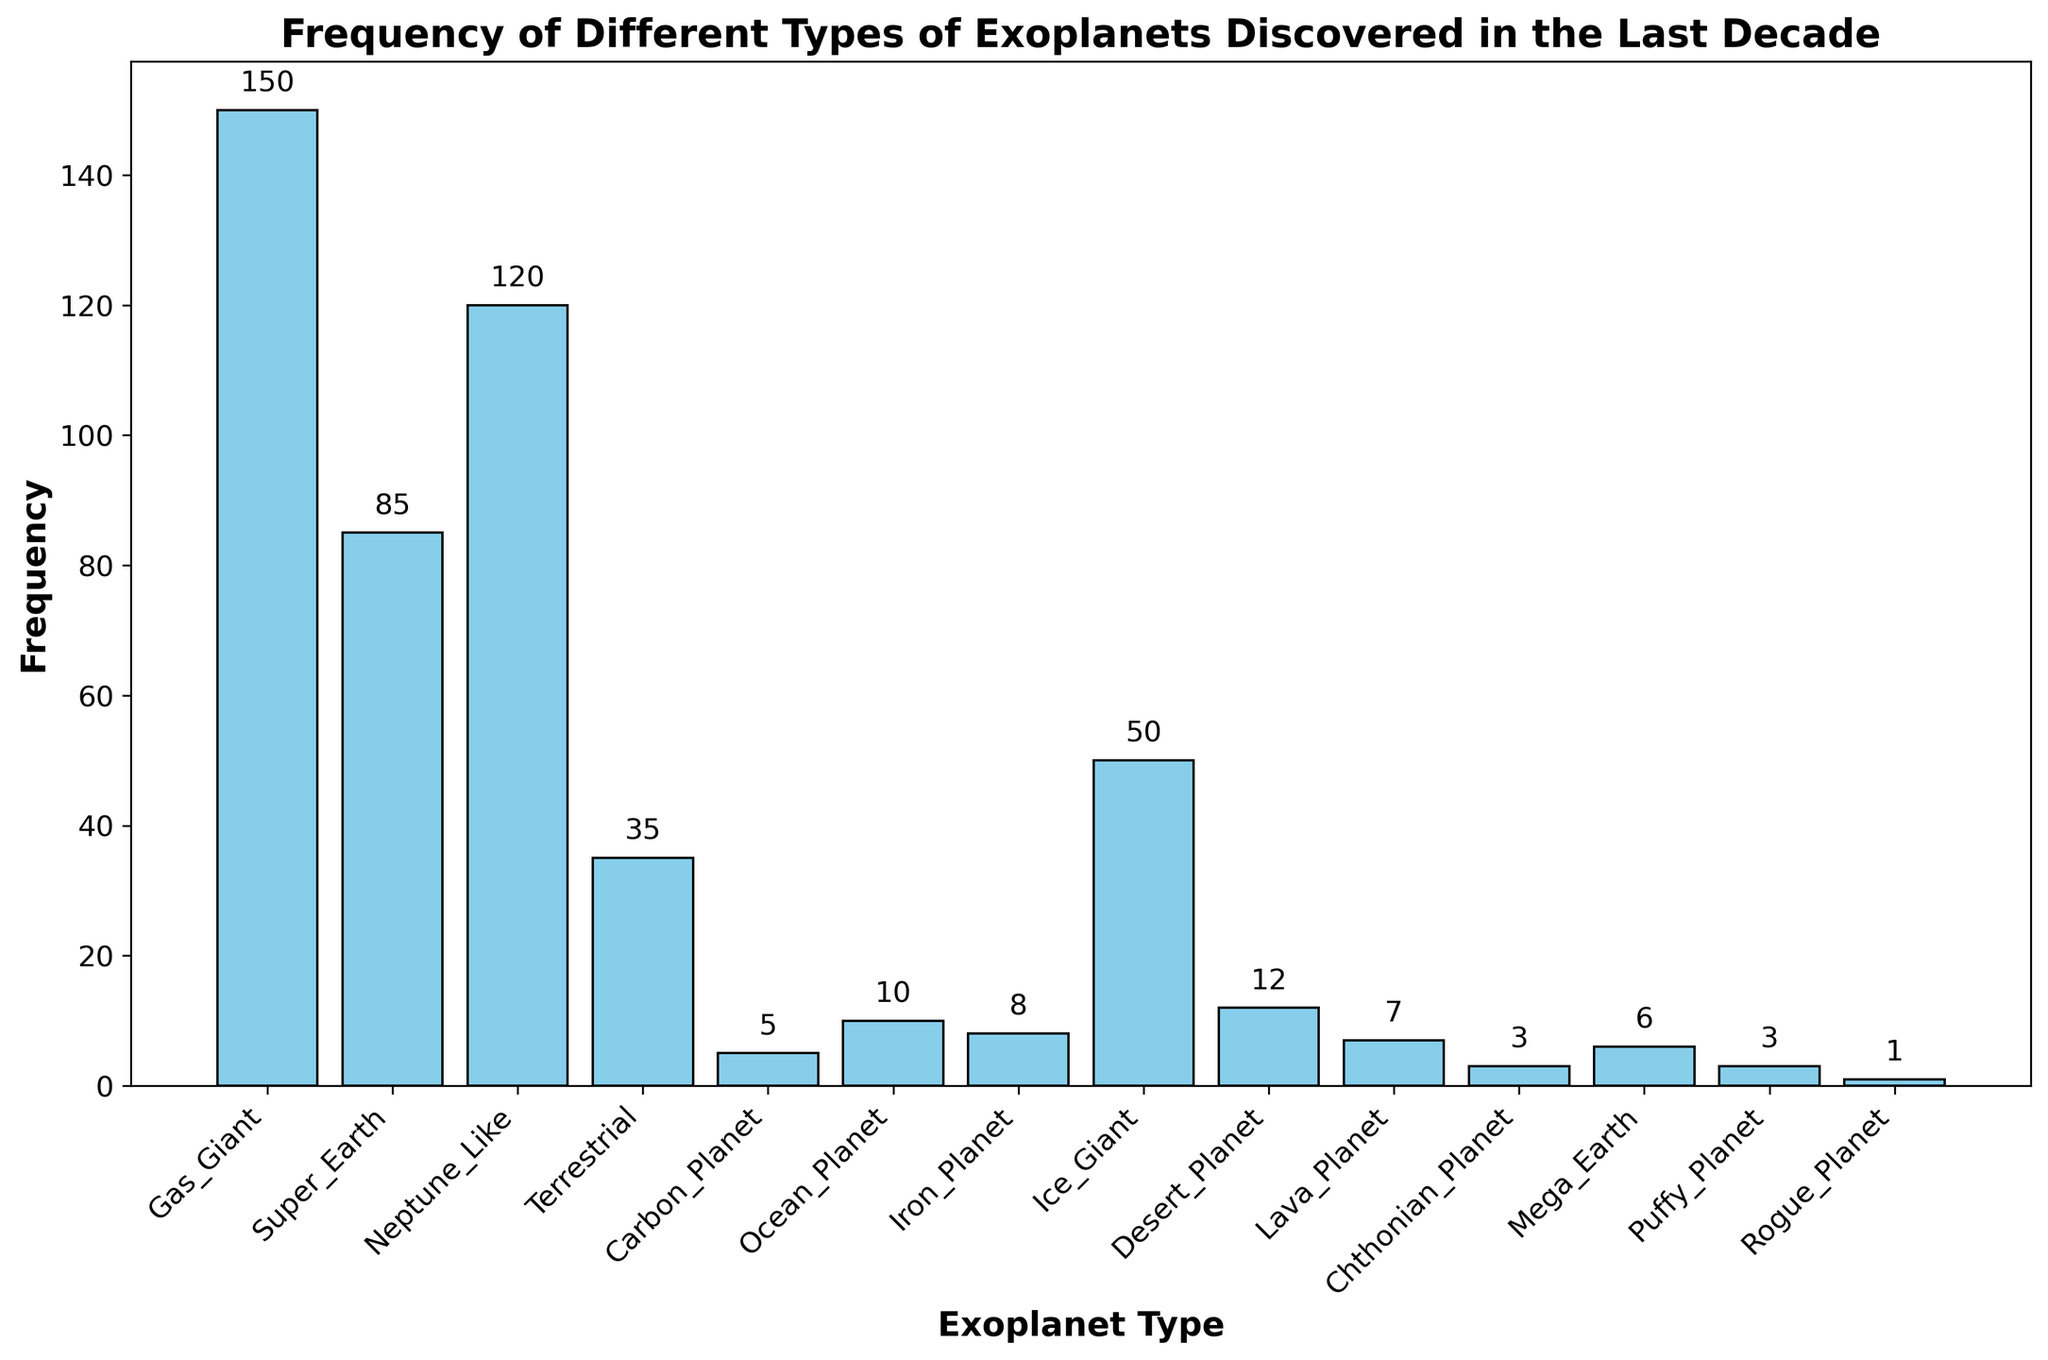What's the most common type of exoplanet discovered? The bar representing the "Gas_Giant" category is the tallest, indicating it has the highest frequency among all the types of exoplanets discovered.
Answer: Gas Giant Which exoplanet types have fewer discoveries than Terrestrial planets? The Terrestrial planet bar is 35 units high. Finding bars shorter than this includes: Carbon Planet (5), Ocean Planet (10), Iron Planet (8), Lava Planet (7), Chthonian Planet (3), Mega Earth (6), Puffy Planet (3), Rogue Planet (1).
Answer: Carbon Planet, Ocean Planet, Iron Planet, Lava Planet, Chthonian Planet, Mega Earth, Puffy Planet, Rogue Planet How many more Gas Giants are there compared to Neptune-Like planets? The height of the Gas Giant bar is 150 and the Neptune-Like bar is 120. Subtract the Neptune-Like frequency from the Gas Giant frequency: 150 - 120 = 30.
Answer: 30 What is the average frequency of the three least discovered exoplanet types? The three types with the lowest frequencies are Rogue Planet (1), Chthonian Planet (3), and Puffy Planet (3). Sum these: 1 + 3 + 3 = 7. Then divide by 3: 7 / 3 ≈ 2.33.
Answer: 2.33 Are there more Neptune-Like or Ice Giant planets discovered? Comparing the heights of Neptune-Like (120) and Ice Giant (50) bars, Neptune-Like has a taller bar.
Answer: Neptune-Like Which exoplanet type has a frequency closest to 10? The Ocean Planet bar has a frequency of 10, which exactly matches 10.
Answer: Ocean Planet What is the frequency range of the exoplanet types discovered? The highest frequency is Gas Giant at 150, and the lowest is Rogue Planet at 1. Subtract the lowest from the highest: 150 - 1 = 149.
Answer: 149 How many exoplanet types have frequencies greater than 50? The types with frequencies above 50 are Gas Giant (150) and Neptune-Like (120). There are 2 types in this range.
Answer: 2 Is the sum of frequencies of Super-Earth and Terrestrial planets greater than that of Gas Giants? Sum frequencies of Super-Earth (85) and Terrestrial (35): 85 + 35 = 120. The frequency of Gas Giant is 150. 120 is less than 150.
Answer: No What are the second and third most common types of exoplanets? The Gas Giant is first with 150. The second highest bar is Neptune-Like at 120, and the third is Super Earth at 85.
Answer: Neptune-Like, Super Earth 